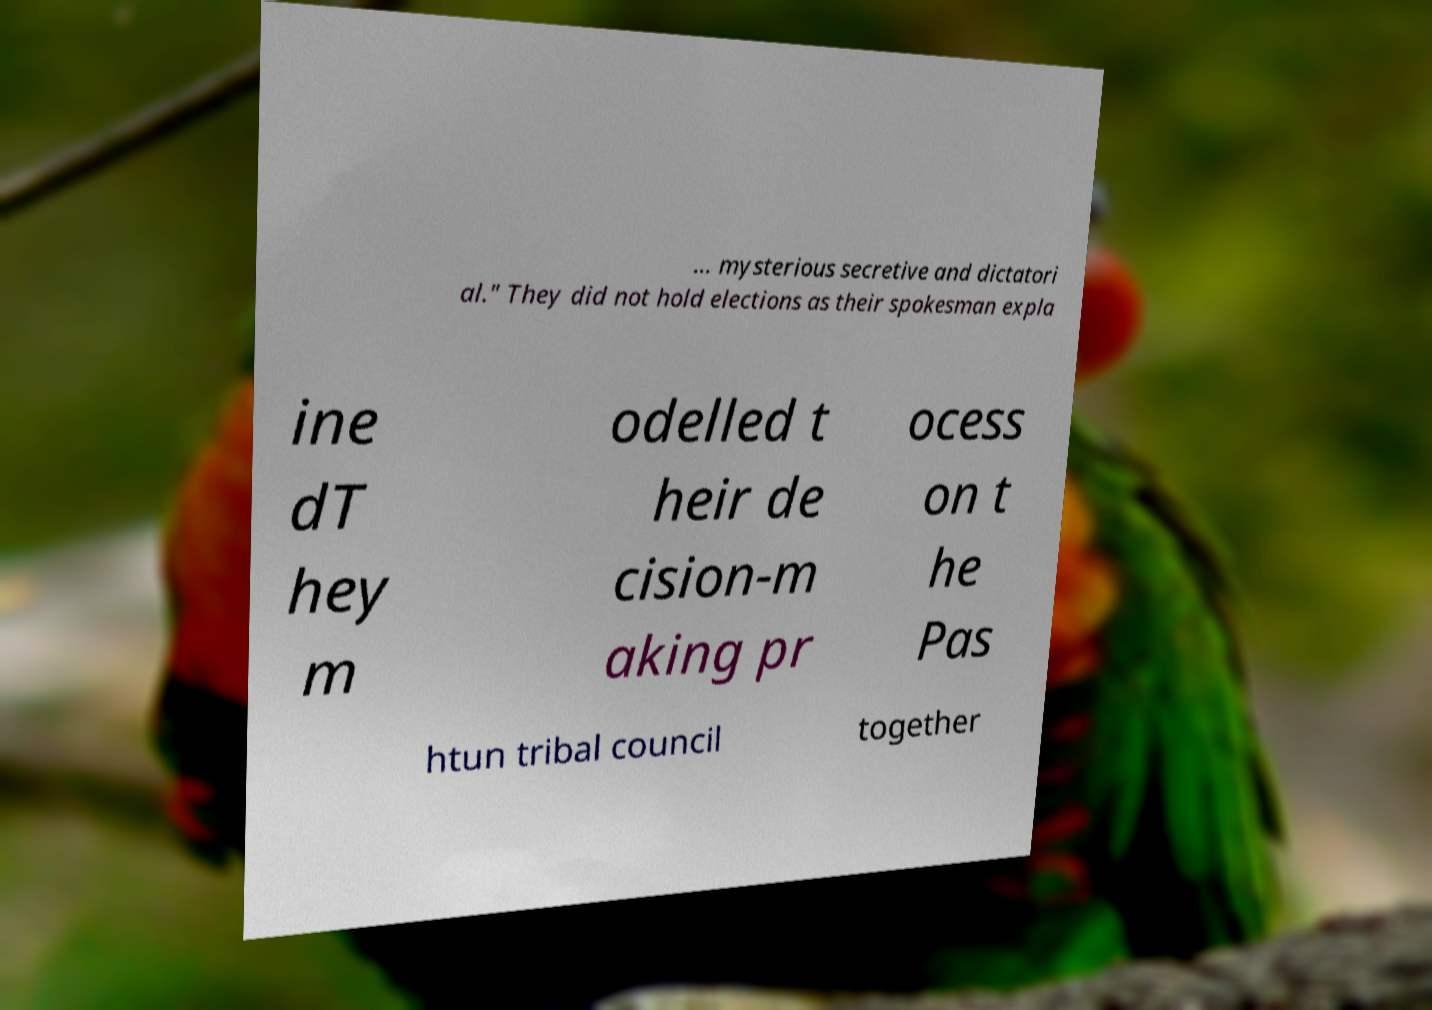For documentation purposes, I need the text within this image transcribed. Could you provide that? ... mysterious secretive and dictatori al." They did not hold elections as their spokesman expla ine dT hey m odelled t heir de cision-m aking pr ocess on t he Pas htun tribal council together 